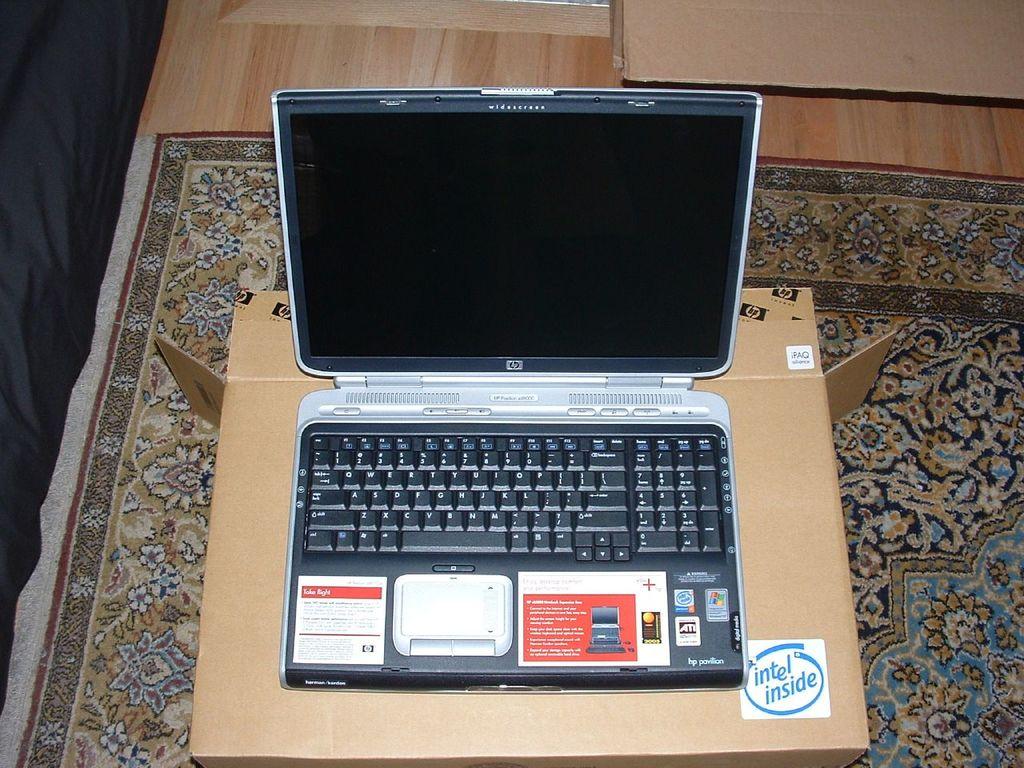What is inside?
Ensure brevity in your answer.  Intel. 